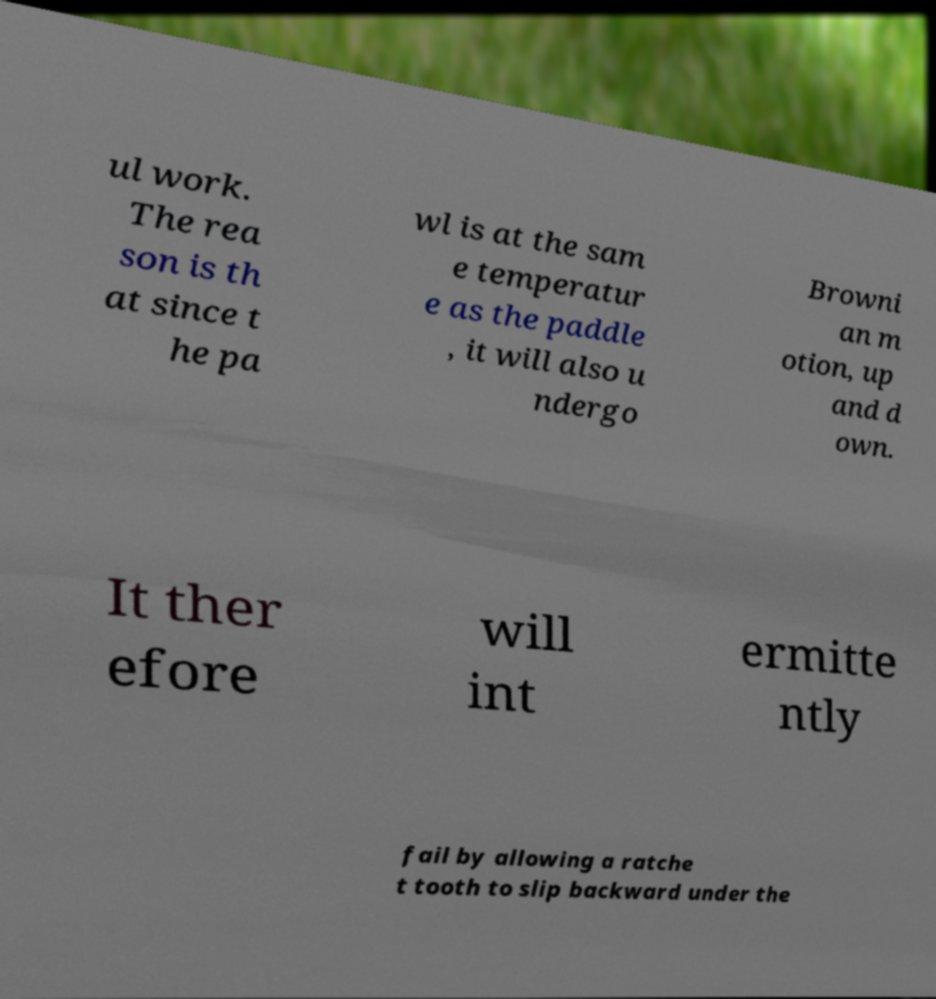Can you read and provide the text displayed in the image?This photo seems to have some interesting text. Can you extract and type it out for me? ul work. The rea son is th at since t he pa wl is at the sam e temperatur e as the paddle , it will also u ndergo Browni an m otion, up and d own. It ther efore will int ermitte ntly fail by allowing a ratche t tooth to slip backward under the 